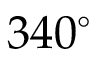Convert formula to latex. <formula><loc_0><loc_0><loc_500><loc_500>3 4 0 ^ { \circ }</formula> 